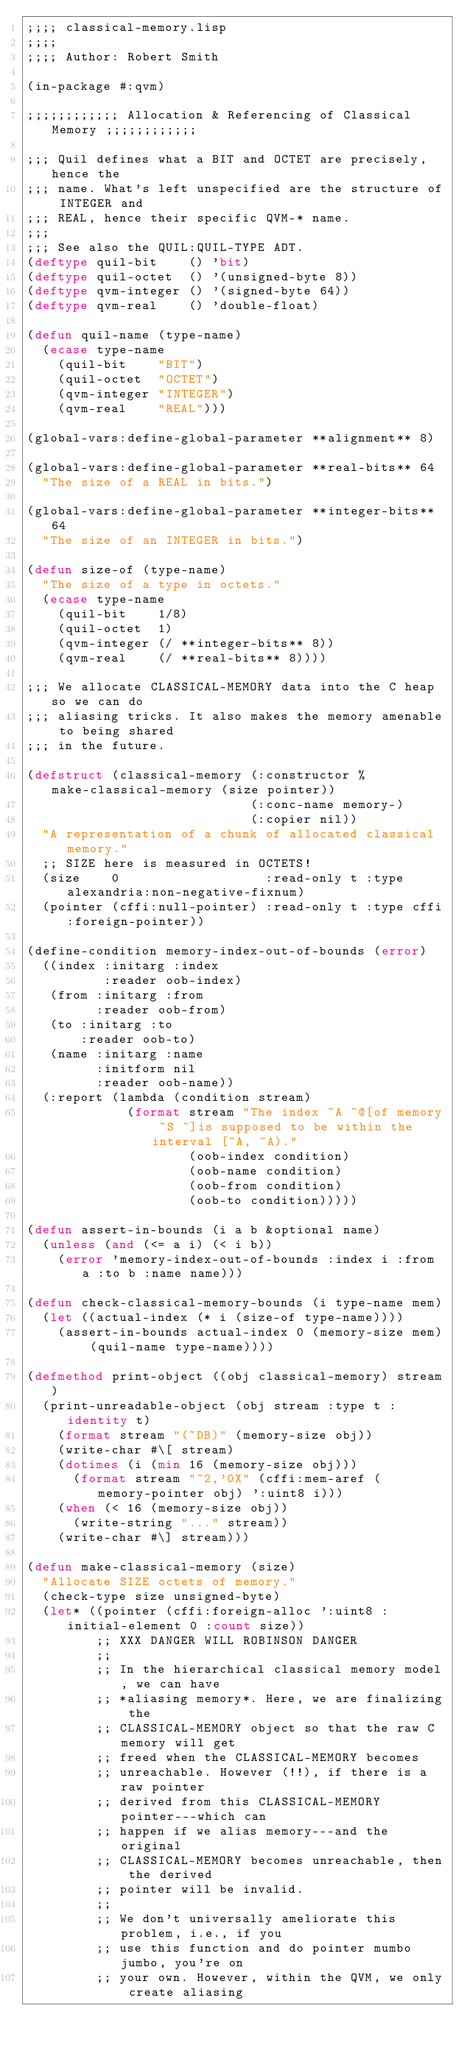Convert code to text. <code><loc_0><loc_0><loc_500><loc_500><_Lisp_>;;;; classical-memory.lisp
;;;;
;;;; Author: Robert Smith

(in-package #:qvm)

;;;;;;;;;;;; Allocation & Referencing of Classical Memory ;;;;;;;;;;;;

;;; Quil defines what a BIT and OCTET are precisely, hence the
;;; name. What's left unspecified are the structure of INTEGER and
;;; REAL, hence their specific QVM-* name.
;;;
;;; See also the QUIL:QUIL-TYPE ADT.
(deftype quil-bit    () 'bit)
(deftype quil-octet  () '(unsigned-byte 8))
(deftype qvm-integer () '(signed-byte 64))
(deftype qvm-real    () 'double-float)

(defun quil-name (type-name)
  (ecase type-name
    (quil-bit    "BIT")
    (quil-octet  "OCTET")
    (qvm-integer "INTEGER")
    (qvm-real    "REAL")))

(global-vars:define-global-parameter **alignment** 8)

(global-vars:define-global-parameter **real-bits** 64
  "The size of a REAL in bits.")

(global-vars:define-global-parameter **integer-bits** 64
  "The size of an INTEGER in bits.")

(defun size-of (type-name)
  "The size of a type in octets."
  (ecase type-name
    (quil-bit    1/8)
    (quil-octet  1)
    (qvm-integer (/ **integer-bits** 8))
    (qvm-real    (/ **real-bits** 8))))

;;; We allocate CLASSICAL-MEMORY data into the C heap so we can do
;;; aliasing tricks. It also makes the memory amenable to being shared
;;; in the future.

(defstruct (classical-memory (:constructor %make-classical-memory (size pointer))
                             (:conc-name memory-)
                             (:copier nil))
  "A representation of a chunk of allocated classical memory."
  ;; SIZE here is measured in OCTETS!
  (size    0                   :read-only t :type alexandria:non-negative-fixnum)
  (pointer (cffi:null-pointer) :read-only t :type cffi:foreign-pointer))

(define-condition memory-index-out-of-bounds (error)
  ((index :initarg :index
          :reader oob-index)
   (from :initarg :from
         :reader oob-from)
   (to :initarg :to
       :reader oob-to)
   (name :initarg :name
         :initform nil
         :reader oob-name))
  (:report (lambda (condition stream)
             (format stream "The index ~A ~@[of memory ~S ~]is supposed to be within the interval [~A, ~A)."
                     (oob-index condition)
                     (oob-name condition)
                     (oob-from condition)
                     (oob-to condition)))))

(defun assert-in-bounds (i a b &optional name)
  (unless (and (<= a i) (< i b))
    (error 'memory-index-out-of-bounds :index i :from a :to b :name name)))

(defun check-classical-memory-bounds (i type-name mem)
  (let ((actual-index (* i (size-of type-name))))
    (assert-in-bounds actual-index 0 (memory-size mem) (quil-name type-name))))

(defmethod print-object ((obj classical-memory) stream)
  (print-unreadable-object (obj stream :type t :identity t)
    (format stream "(~DB)" (memory-size obj))
    (write-char #\[ stream)
    (dotimes (i (min 16 (memory-size obj)))
      (format stream "~2,'0X" (cffi:mem-aref (memory-pointer obj) ':uint8 i)))
    (when (< 16 (memory-size obj))
      (write-string "..." stream))
    (write-char #\] stream)))

(defun make-classical-memory (size)
  "Allocate SIZE octets of memory."
  (check-type size unsigned-byte)
  (let* ((pointer (cffi:foreign-alloc ':uint8 :initial-element 0 :count size))
         ;; XXX DANGER WILL ROBINSON DANGER
         ;;
         ;; In the hierarchical classical memory model, we can have
         ;; *aliasing memory*. Here, we are finalizing the
         ;; CLASSICAL-MEMORY object so that the raw C memory will get
         ;; freed when the CLASSICAL-MEMORY becomes
         ;; unreachable. However (!!), if there is a raw pointer
         ;; derived from this CLASSICAL-MEMORY pointer---which can
         ;; happen if we alias memory---and the original
         ;; CLASSICAL-MEMORY becomes unreachable, then the derived
         ;; pointer will be invalid.
         ;;
         ;; We don't universally ameliorate this problem, i.e., if you
         ;; use this function and do pointer mumbo jumbo, you're on
         ;; your own. However, within the QVM, we only create aliasing</code> 